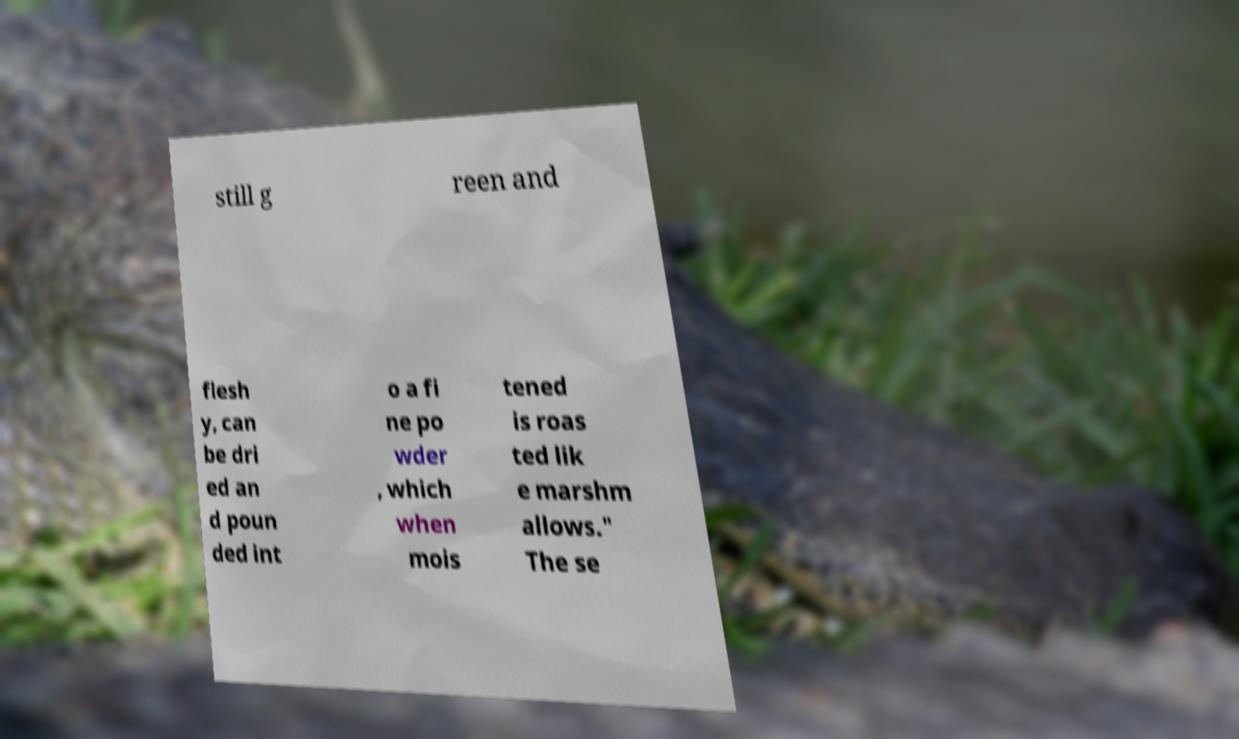Can you accurately transcribe the text from the provided image for me? still g reen and flesh y, can be dri ed an d poun ded int o a fi ne po wder , which when mois tened is roas ted lik e marshm allows." The se 